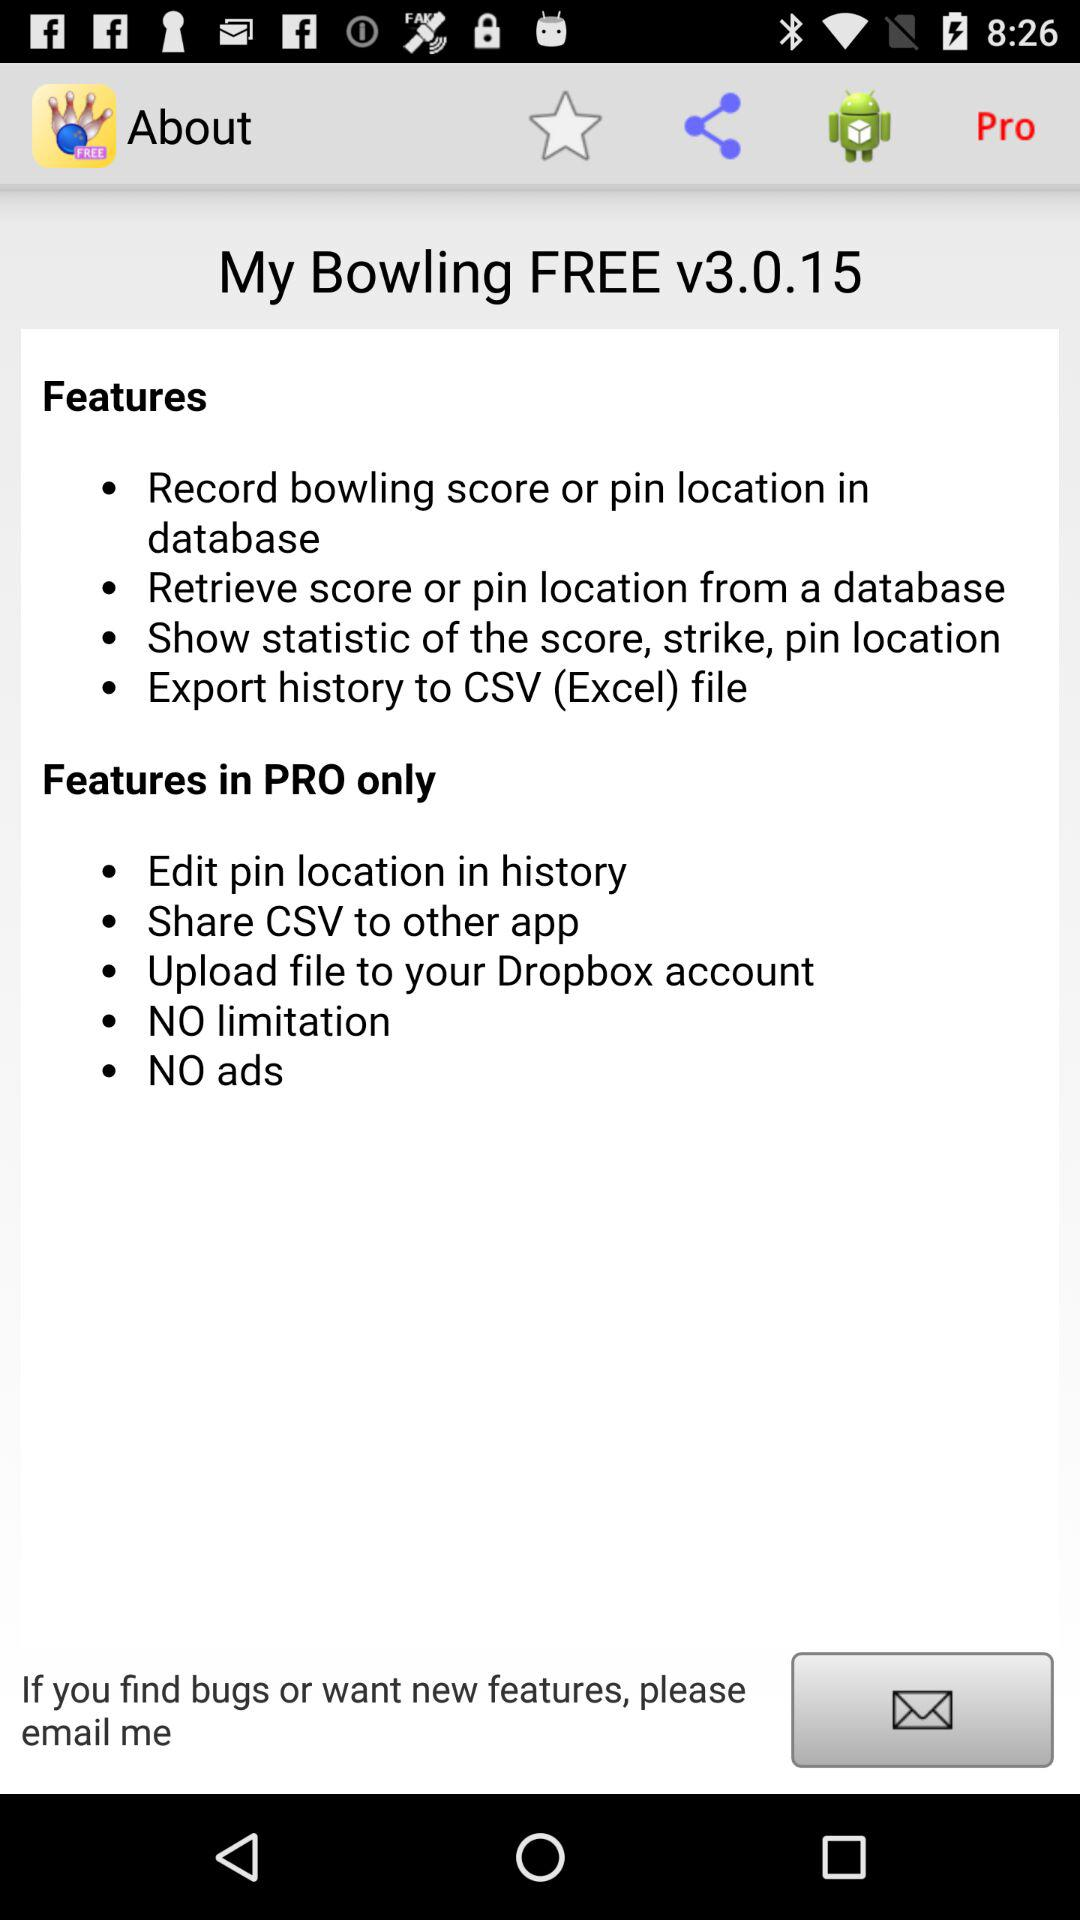How many features are in the free version?
Answer the question using a single word or phrase. 4 